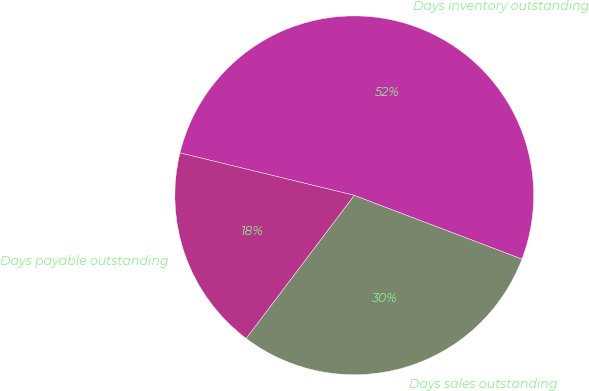Convert chart to OTSL. <chart><loc_0><loc_0><loc_500><loc_500><pie_chart><fcel>Days sales outstanding<fcel>Days inventory outstanding<fcel>Days payable outstanding<nl><fcel>29.52%<fcel>51.98%<fcel>18.5%<nl></chart> 